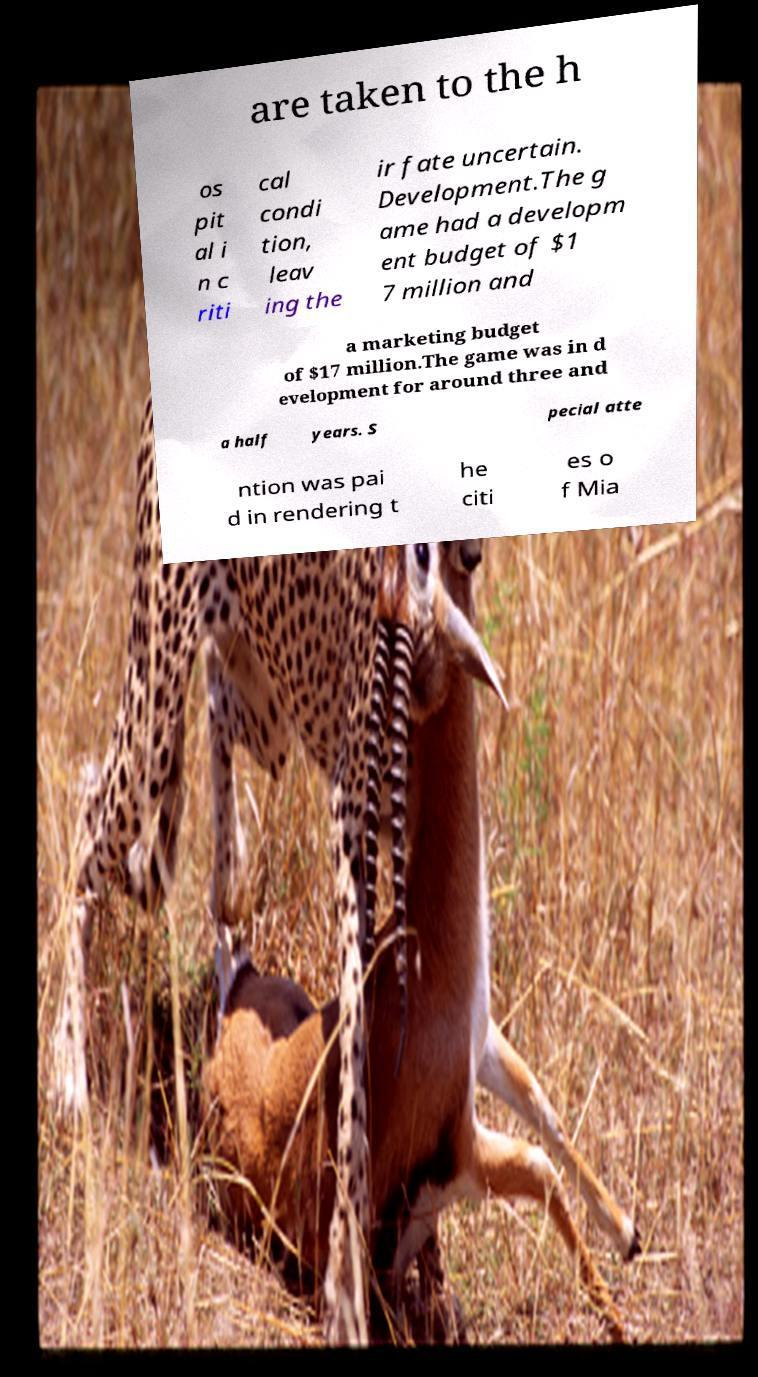Please identify and transcribe the text found in this image. are taken to the h os pit al i n c riti cal condi tion, leav ing the ir fate uncertain. Development.The g ame had a developm ent budget of $1 7 million and a marketing budget of $17 million.The game was in d evelopment for around three and a half years. S pecial atte ntion was pai d in rendering t he citi es o f Mia 